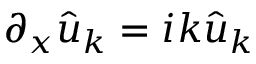Convert formula to latex. <formula><loc_0><loc_0><loc_500><loc_500>\partial _ { x } \hat { u } _ { k } = i k \hat { u } _ { k }</formula> 